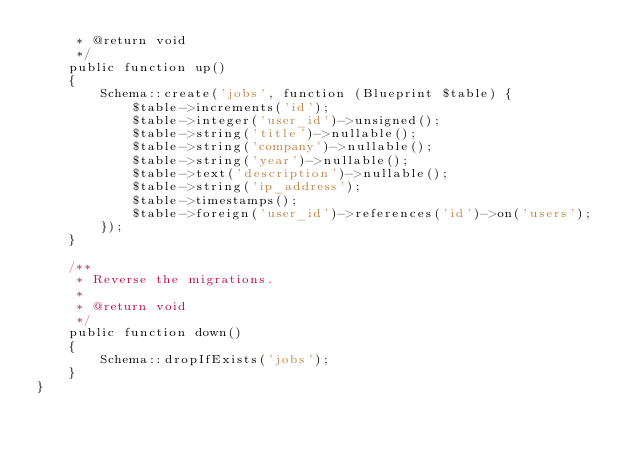Convert code to text. <code><loc_0><loc_0><loc_500><loc_500><_PHP_>     * @return void
     */
    public function up()
    {
        Schema::create('jobs', function (Blueprint $table) {
            $table->increments('id');
            $table->integer('user_id')->unsigned();
            $table->string('title')->nullable();
            $table->string('company')->nullable();
            $table->string('year')->nullable();
            $table->text('description')->nullable();
            $table->string('ip_address');
            $table->timestamps();
            $table->foreign('user_id')->references('id')->on('users');
        });
    }

    /**
     * Reverse the migrations.
     *
     * @return void
     */
    public function down()
    {
        Schema::dropIfExists('jobs');
    }
}
</code> 